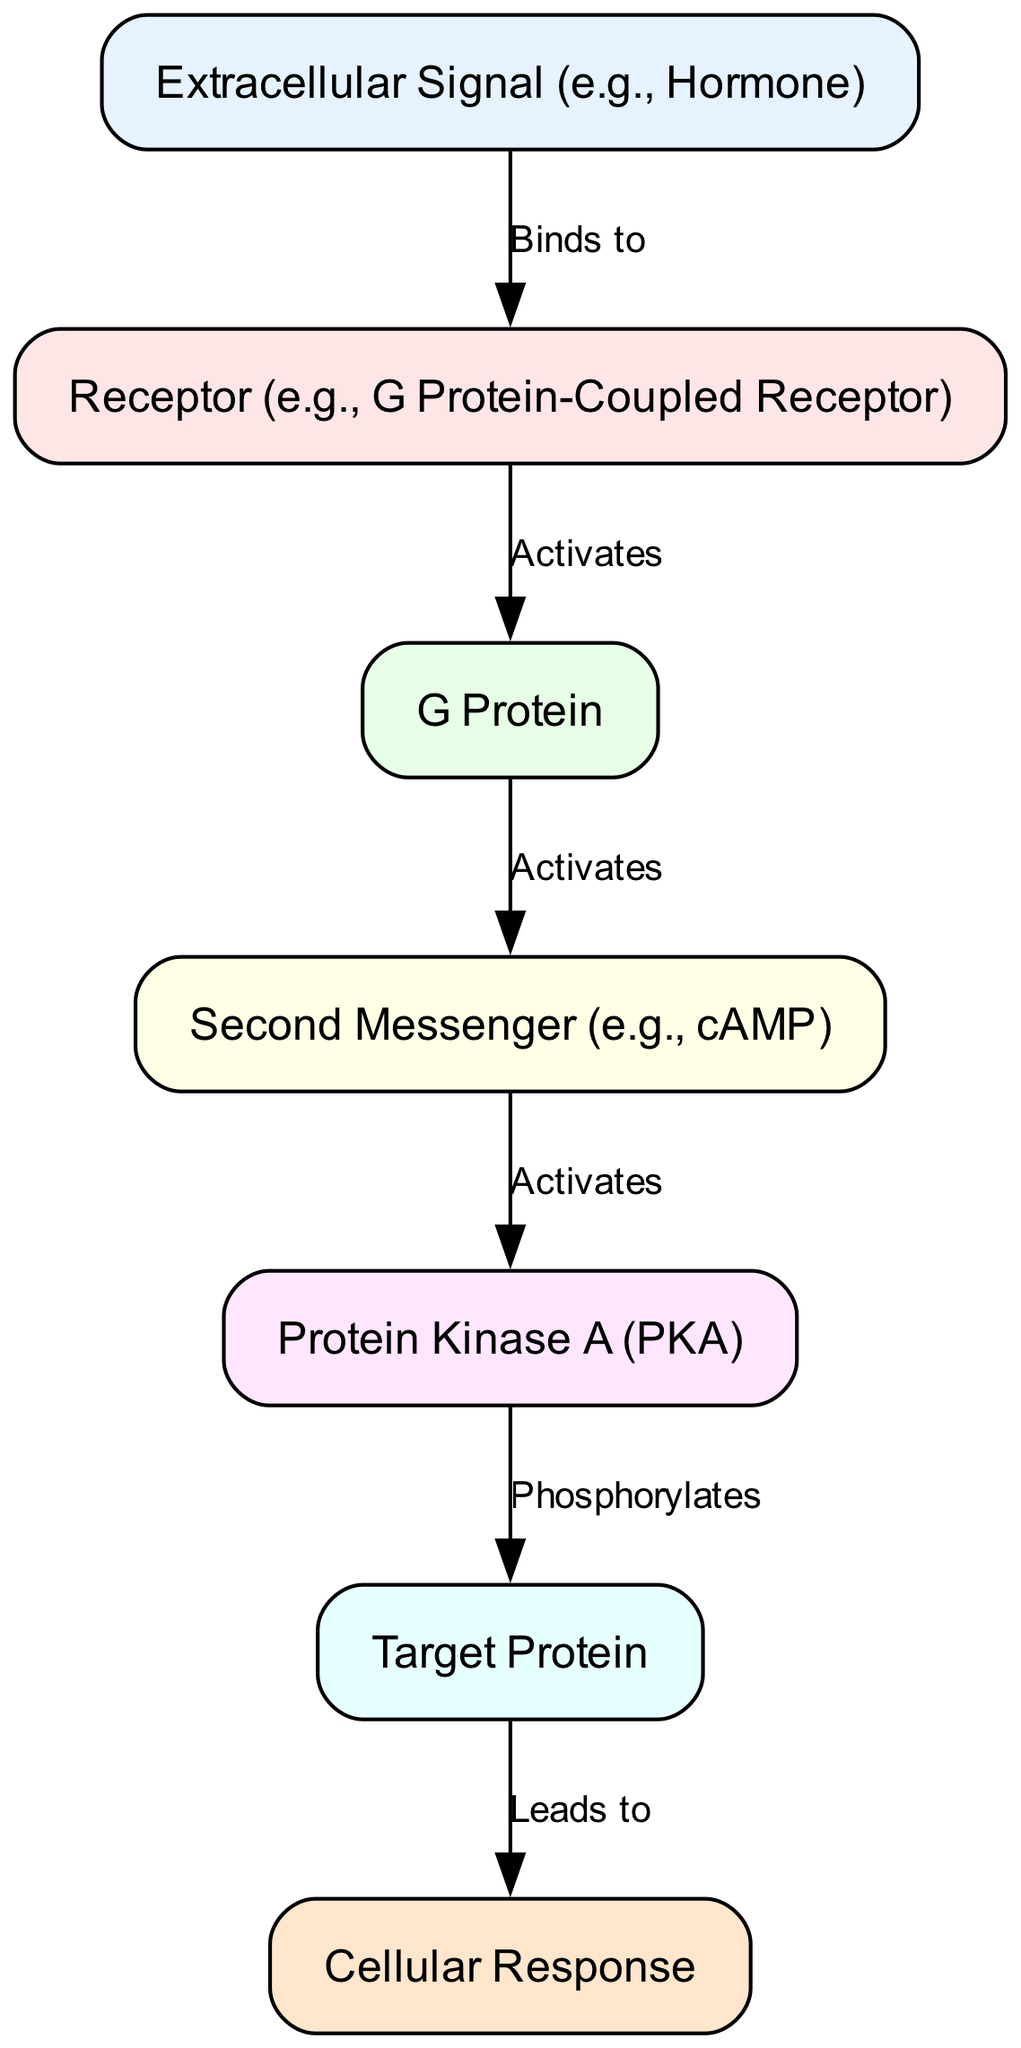What is the first node in the signaling pathway? The first node in the signaling pathway is the "Extracellular Signal (e.g., Hormone)" which initiates the process of signal transduction.
Answer: Extracellular Signal (e.g., Hormone) How many nodes are in the diagram? The diagram contains a total of seven nodes representing different components of the cell signaling pathway.
Answer: 7 What does the receptor activate? The receptor activates the "G Protein" which is the next component in the signaling sequence after the binding of the extracellular signal.
Answer: G Protein Which molecule carries out phosphorylation in the pathway? The "Protein Kinase A (PKA)" is the molecule responsible for phosphorylating the target protein as indicated in the sequence of the signaling pathway.
Answer: Protein Kinase A (PKA) What is the final outcome of the signaling pathway? The final outcome of the signaling pathway is termed as "Cellular Response" which represents the biological effect triggered by the signal transduction process.
Answer: Cellular Response Which node represents the second messenger in the pathway? The "Second Messenger (e.g., cAMP)" serves as the intermediate signaling molecule activated by the G Protein and is crucial for further downstream signaling events.
Answer: Second Messenger (e.g., cAMP) What role does the second messenger play in the diagram? The second messenger activates the "Protein Kinase A (PKA)", facilitating a cascade of phosphorylation events that ultimately lead to the cellular response.
Answer: Activates How is the target protein modified in this pathway? The target protein is modified through a process of phosphorylation, as indicated by the edge labeled "Phosphorylates" connecting Protein Kinase A to the target protein.
Answer: Phosphorylation What is the relationship between the extracellular signal and the receptor? The relationship is that the extracellular signal binds to the receptor, initiating the entire signal transduction pathway.
Answer: Binds to 